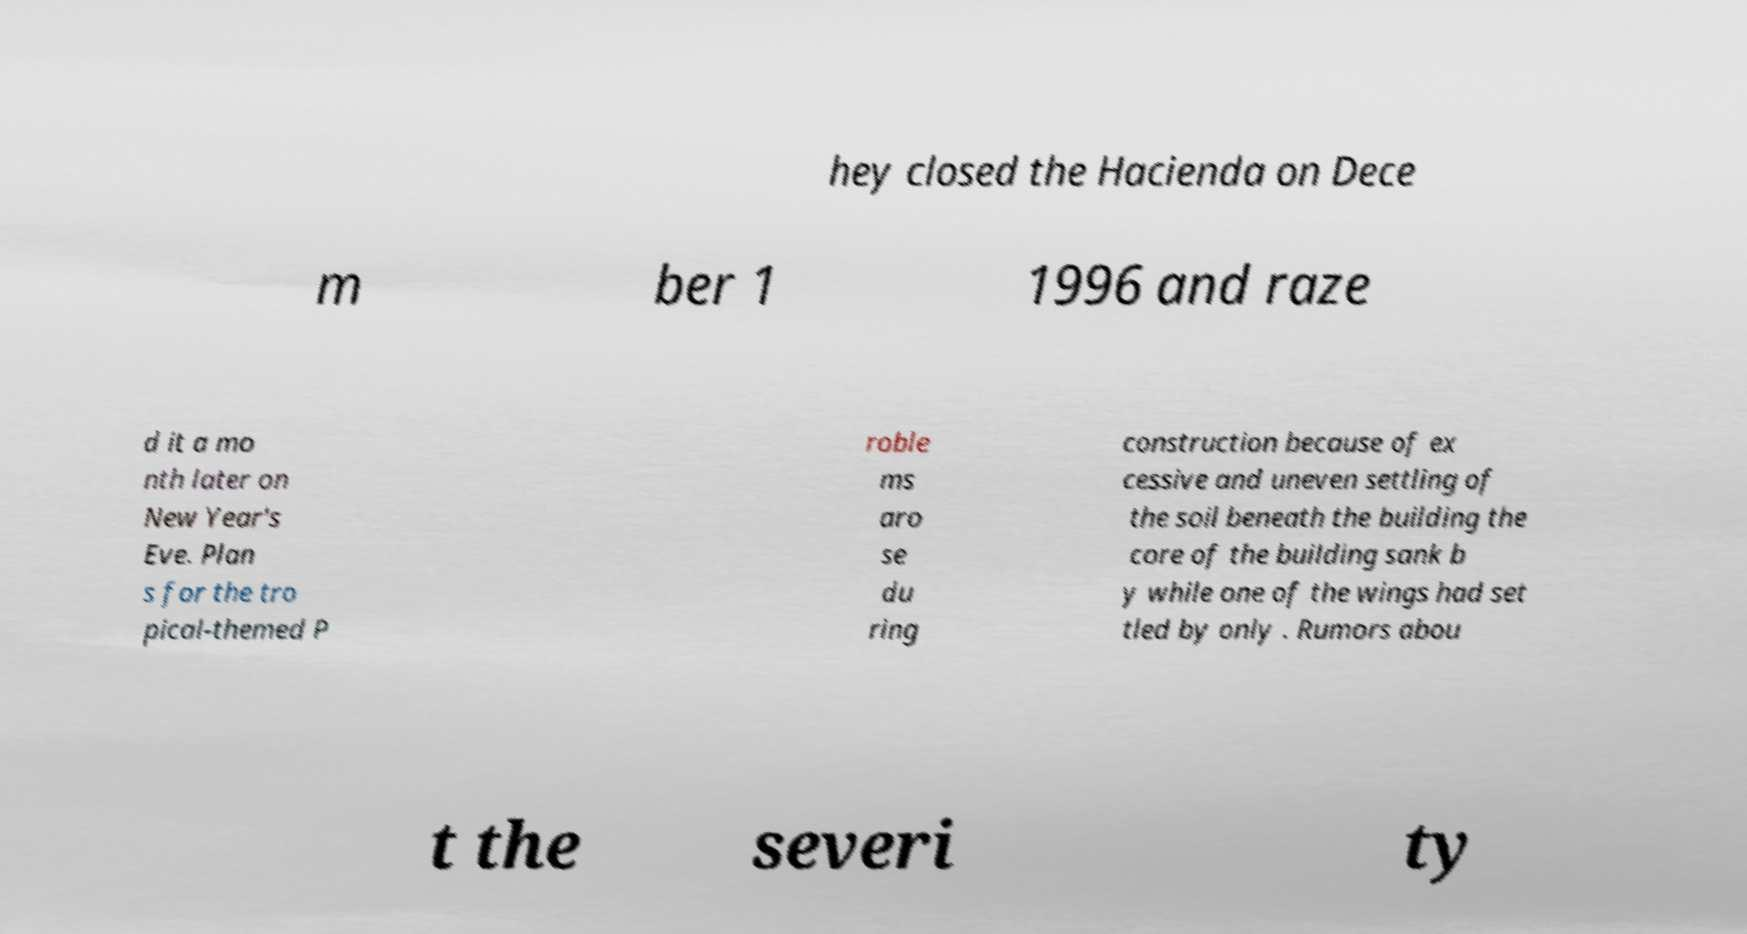I need the written content from this picture converted into text. Can you do that? hey closed the Hacienda on Dece m ber 1 1996 and raze d it a mo nth later on New Year's Eve. Plan s for the tro pical-themed P roble ms aro se du ring construction because of ex cessive and uneven settling of the soil beneath the building the core of the building sank b y while one of the wings had set tled by only . Rumors abou t the severi ty 